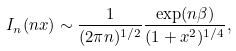<formula> <loc_0><loc_0><loc_500><loc_500>I _ { n } ( n x ) \sim \frac { 1 } { ( 2 \pi n ) ^ { 1 / 2 } } \frac { \exp ( n \beta ) } { ( 1 + x ^ { 2 } ) ^ { 1 / 4 } } ,</formula> 